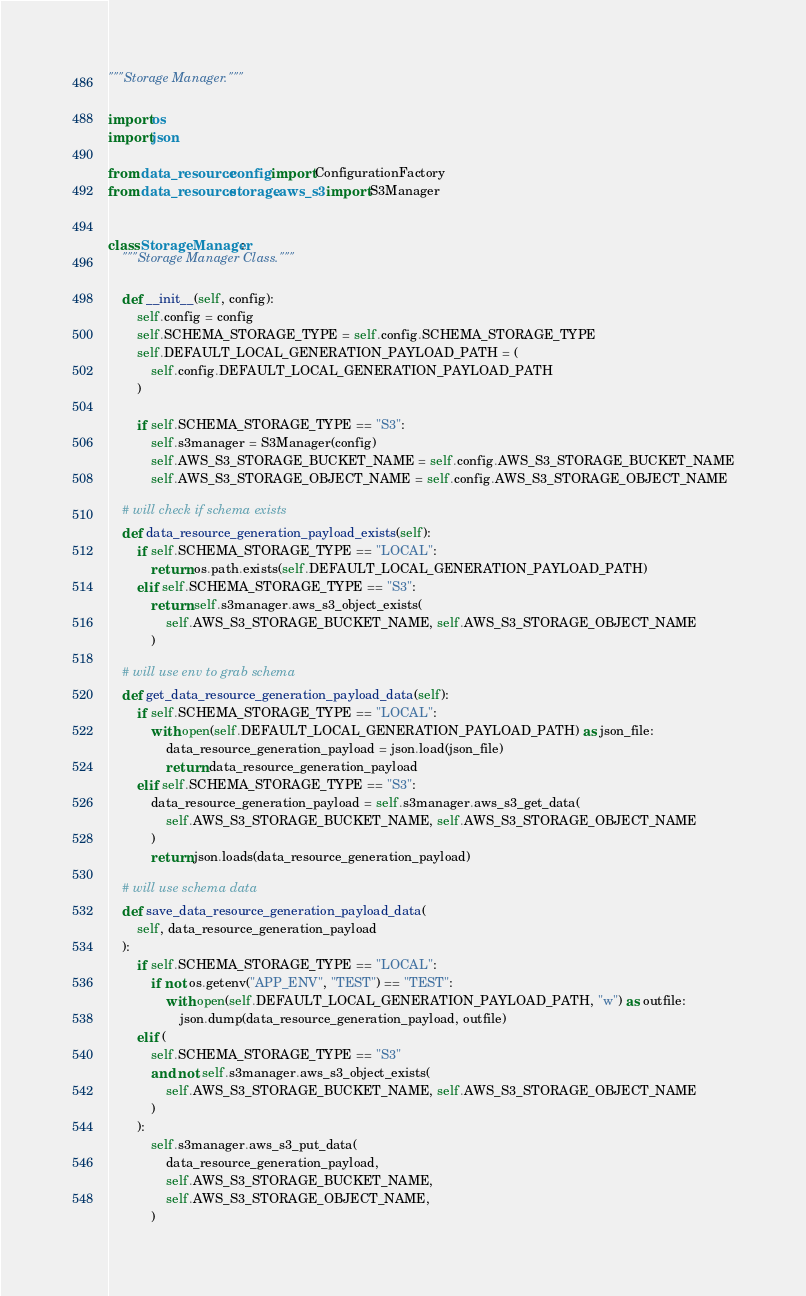Convert code to text. <code><loc_0><loc_0><loc_500><loc_500><_Python_>"""Storage Manager."""

import os
import json

from data_resource.config import ConfigurationFactory
from data_resource.storage.aws_s3 import S3Manager


class StorageManager:
    """Storage Manager Class."""

    def __init__(self, config):
        self.config = config
        self.SCHEMA_STORAGE_TYPE = self.config.SCHEMA_STORAGE_TYPE
        self.DEFAULT_LOCAL_GENERATION_PAYLOAD_PATH = (
            self.config.DEFAULT_LOCAL_GENERATION_PAYLOAD_PATH
        )

        if self.SCHEMA_STORAGE_TYPE == "S3":
            self.s3manager = S3Manager(config)
            self.AWS_S3_STORAGE_BUCKET_NAME = self.config.AWS_S3_STORAGE_BUCKET_NAME
            self.AWS_S3_STORAGE_OBJECT_NAME = self.config.AWS_S3_STORAGE_OBJECT_NAME

    # will check if schema exists
    def data_resource_generation_payload_exists(self):
        if self.SCHEMA_STORAGE_TYPE == "LOCAL":
            return os.path.exists(self.DEFAULT_LOCAL_GENERATION_PAYLOAD_PATH)
        elif self.SCHEMA_STORAGE_TYPE == "S3":
            return self.s3manager.aws_s3_object_exists(
                self.AWS_S3_STORAGE_BUCKET_NAME, self.AWS_S3_STORAGE_OBJECT_NAME
            )

    # will use env to grab schema
    def get_data_resource_generation_payload_data(self):
        if self.SCHEMA_STORAGE_TYPE == "LOCAL":
            with open(self.DEFAULT_LOCAL_GENERATION_PAYLOAD_PATH) as json_file:
                data_resource_generation_payload = json.load(json_file)
                return data_resource_generation_payload
        elif self.SCHEMA_STORAGE_TYPE == "S3":
            data_resource_generation_payload = self.s3manager.aws_s3_get_data(
                self.AWS_S3_STORAGE_BUCKET_NAME, self.AWS_S3_STORAGE_OBJECT_NAME
            )
            return json.loads(data_resource_generation_payload)

    # will use schema data
    def save_data_resource_generation_payload_data(
        self, data_resource_generation_payload
    ):
        if self.SCHEMA_STORAGE_TYPE == "LOCAL":
            if not os.getenv("APP_ENV", "TEST") == "TEST":
                with open(self.DEFAULT_LOCAL_GENERATION_PAYLOAD_PATH, "w") as outfile:
                    json.dump(data_resource_generation_payload, outfile)
        elif (
            self.SCHEMA_STORAGE_TYPE == "S3"
            and not self.s3manager.aws_s3_object_exists(
                self.AWS_S3_STORAGE_BUCKET_NAME, self.AWS_S3_STORAGE_OBJECT_NAME
            )
        ):
            self.s3manager.aws_s3_put_data(
                data_resource_generation_payload,
                self.AWS_S3_STORAGE_BUCKET_NAME,
                self.AWS_S3_STORAGE_OBJECT_NAME,
            )
</code> 